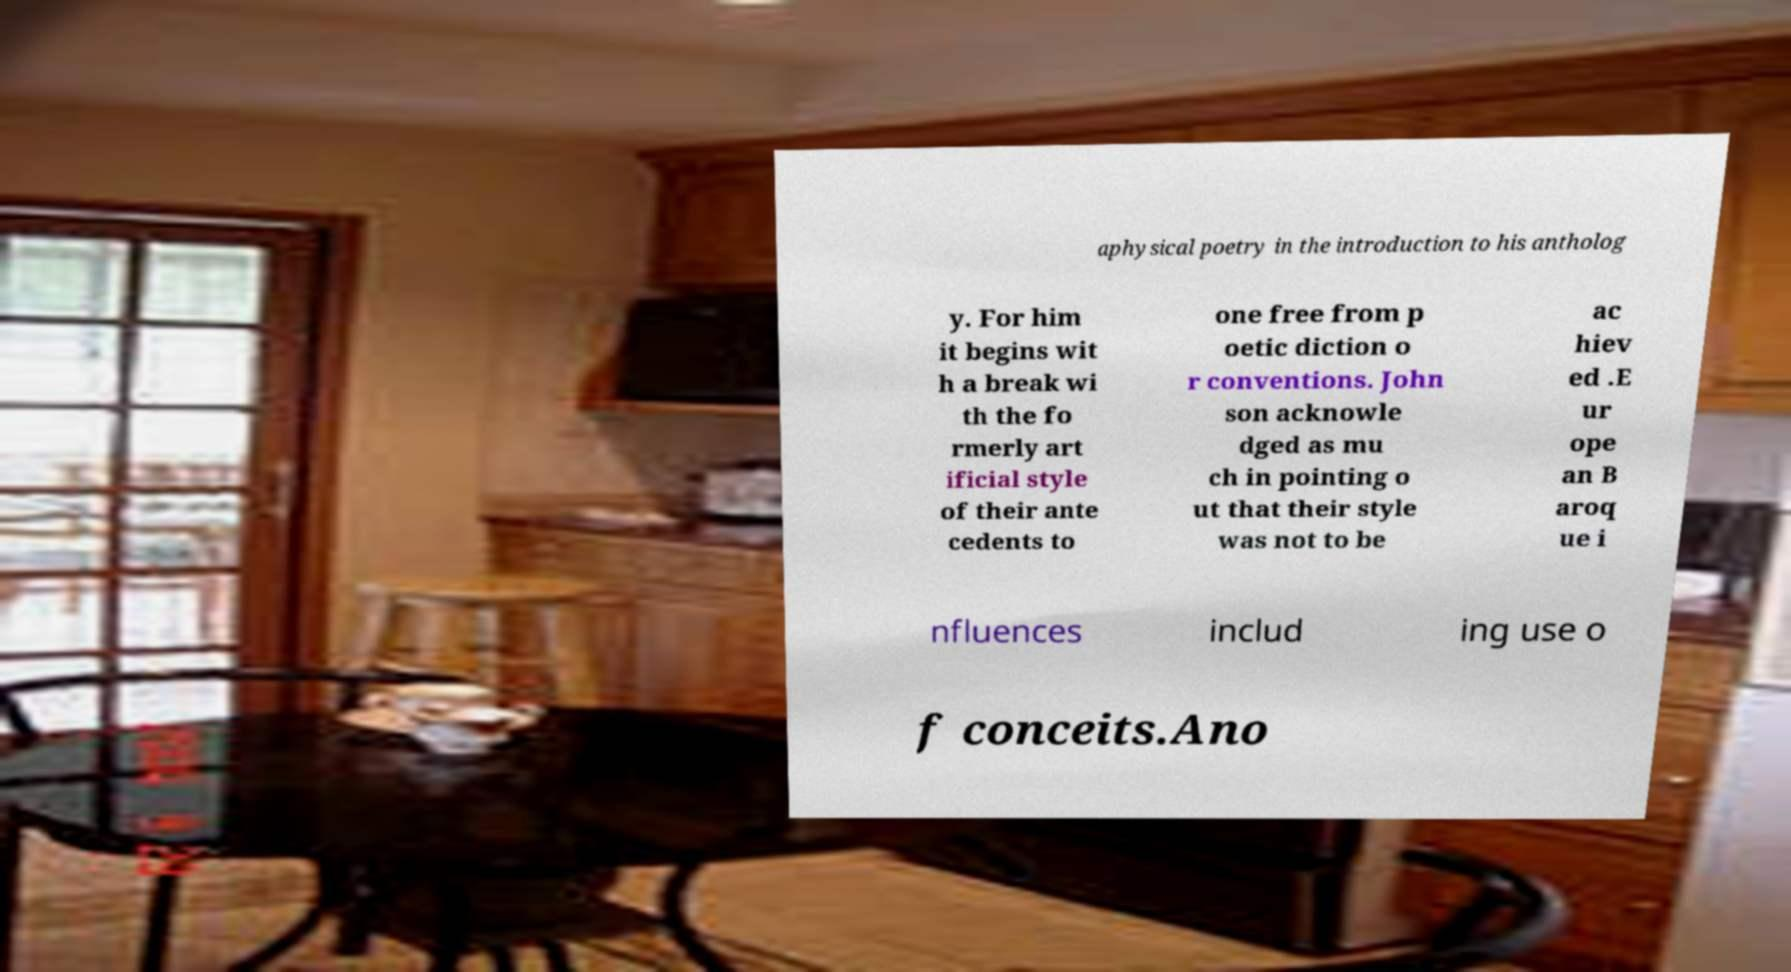For documentation purposes, I need the text within this image transcribed. Could you provide that? aphysical poetry in the introduction to his antholog y. For him it begins wit h a break wi th the fo rmerly art ificial style of their ante cedents to one free from p oetic diction o r conventions. John son acknowle dged as mu ch in pointing o ut that their style was not to be ac hiev ed .E ur ope an B aroq ue i nfluences includ ing use o f conceits.Ano 